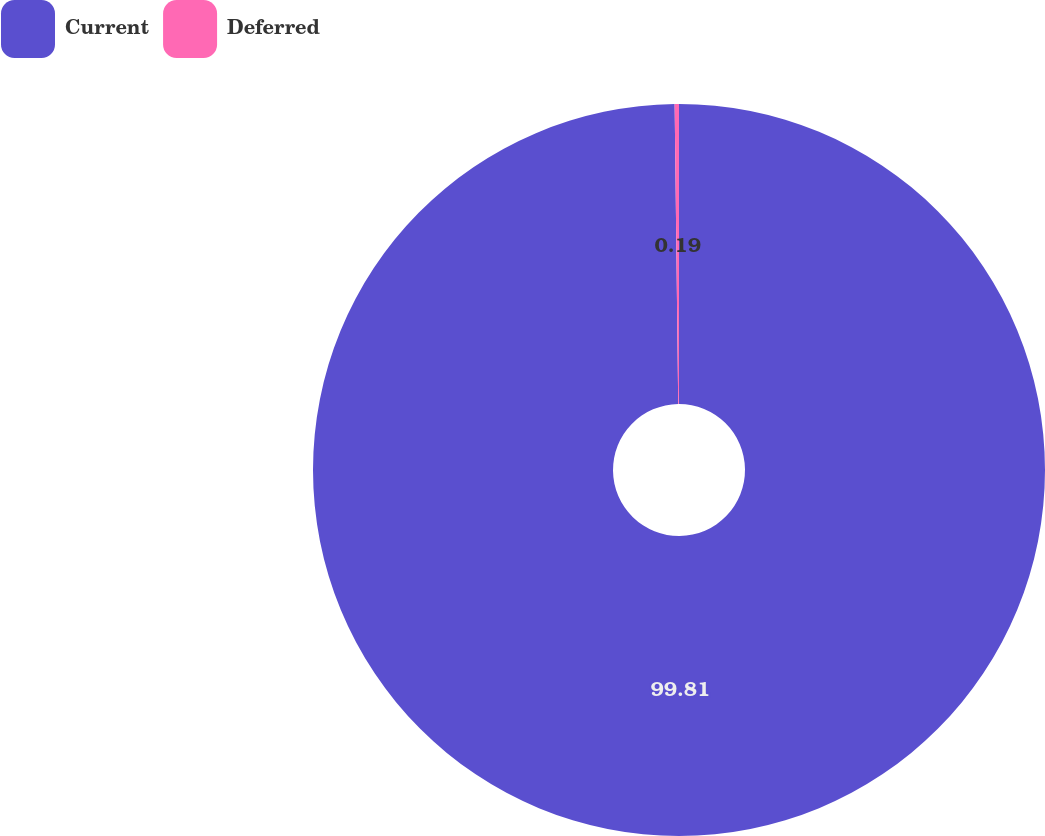Convert chart. <chart><loc_0><loc_0><loc_500><loc_500><pie_chart><fcel>Current<fcel>Deferred<nl><fcel>99.81%<fcel>0.19%<nl></chart> 